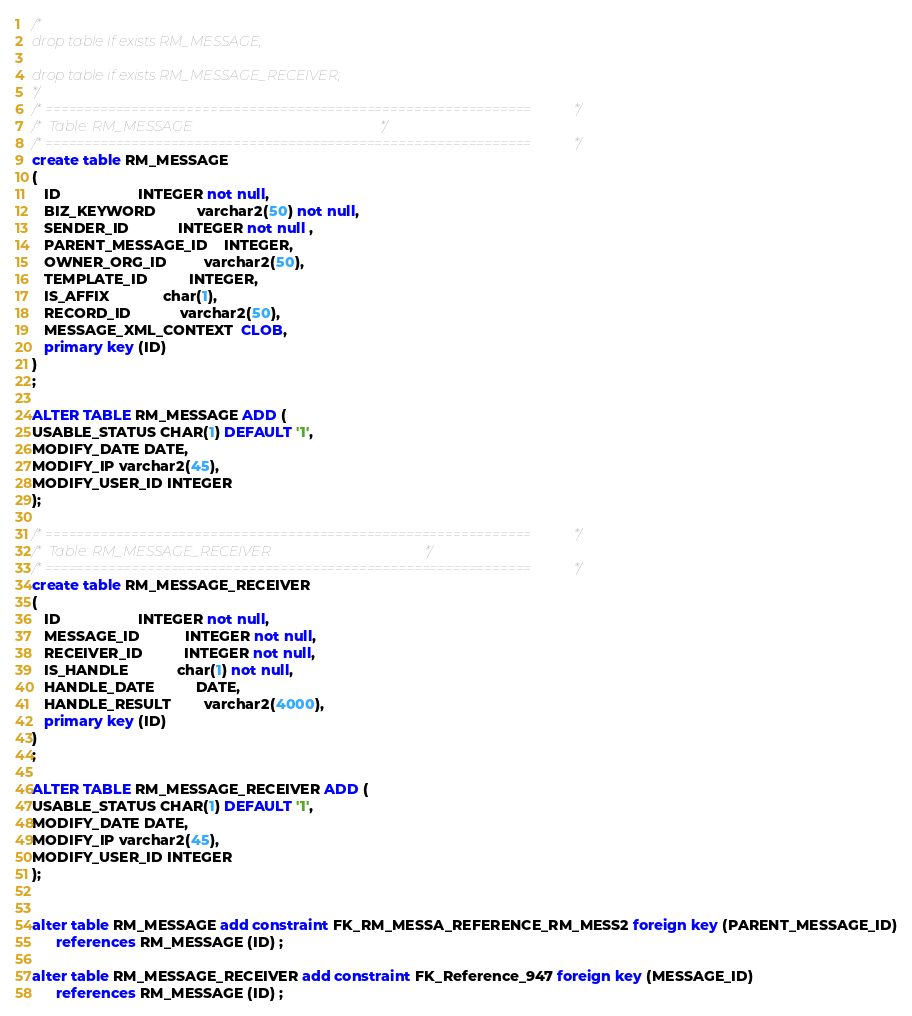Convert code to text. <code><loc_0><loc_0><loc_500><loc_500><_SQL_>/*
drop table if exists RM_MESSAGE;

drop table if exists RM_MESSAGE_RECEIVER;
*/
/*==============================================================*/
/* Table: RM_MESSAGE                                            */
/*==============================================================*/
create table RM_MESSAGE
(
   ID                   INTEGER not null,
   BIZ_KEYWORD          varchar2(50) not null,
   SENDER_ID            INTEGER not null ,
   PARENT_MESSAGE_ID    INTEGER,
   OWNER_ORG_ID         varchar2(50),
   TEMPLATE_ID          INTEGER,
   IS_AFFIX             char(1),
   RECORD_ID            varchar2(50),
   MESSAGE_XML_CONTEXT  CLOB,
   primary key (ID)
)
;

ALTER TABLE RM_MESSAGE ADD (
USABLE_STATUS CHAR(1) DEFAULT '1',
MODIFY_DATE DATE,
MODIFY_IP varchar2(45),
MODIFY_USER_ID INTEGER
);

/*==============================================================*/
/* Table: RM_MESSAGE_RECEIVER                                   */
/*==============================================================*/
create table RM_MESSAGE_RECEIVER
(
   ID                   INTEGER not null,
   MESSAGE_ID           INTEGER not null,
   RECEIVER_ID          INTEGER not null,
   IS_HANDLE            char(1) not null,
   HANDLE_DATE          DATE,
   HANDLE_RESULT        varchar2(4000),
   primary key (ID)
)
;

ALTER TABLE RM_MESSAGE_RECEIVER ADD (
USABLE_STATUS CHAR(1) DEFAULT '1',
MODIFY_DATE DATE,
MODIFY_IP varchar2(45),
MODIFY_USER_ID INTEGER
);


alter table RM_MESSAGE add constraint FK_RM_MESSA_REFERENCE_RM_MESS2 foreign key (PARENT_MESSAGE_ID)
      references RM_MESSAGE (ID) ;

alter table RM_MESSAGE_RECEIVER add constraint FK_Reference_947 foreign key (MESSAGE_ID)
      references RM_MESSAGE (ID) ;
</code> 